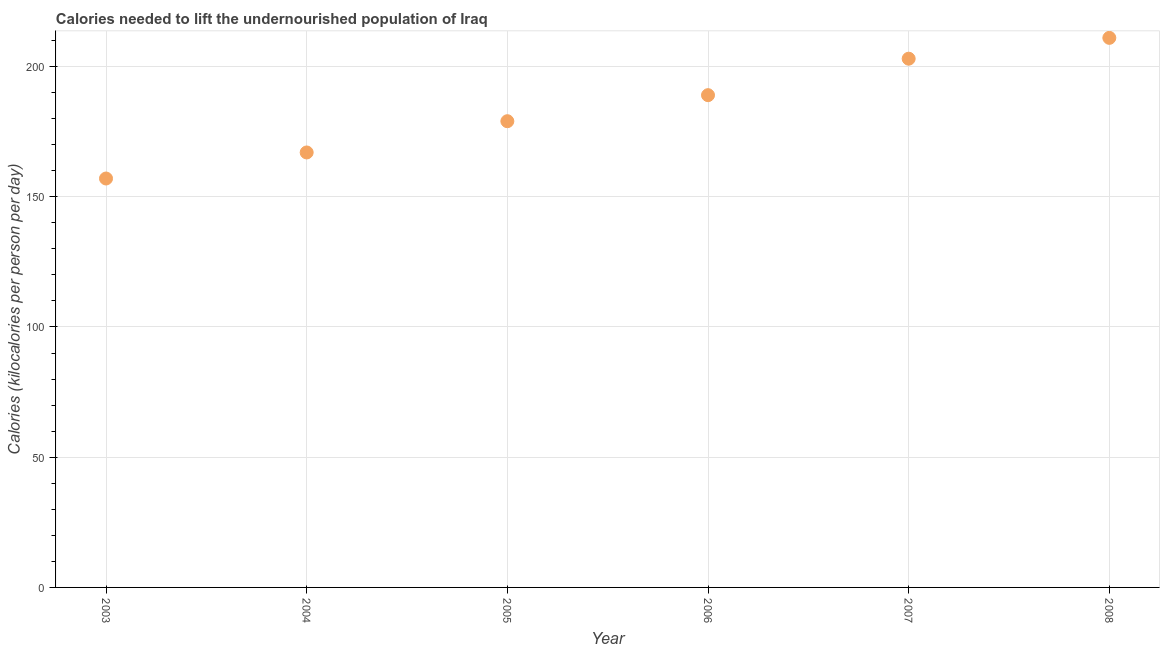What is the depth of food deficit in 2004?
Your answer should be very brief. 167. Across all years, what is the maximum depth of food deficit?
Your answer should be very brief. 211. Across all years, what is the minimum depth of food deficit?
Give a very brief answer. 157. In which year was the depth of food deficit maximum?
Your answer should be very brief. 2008. What is the sum of the depth of food deficit?
Give a very brief answer. 1106. What is the difference between the depth of food deficit in 2004 and 2005?
Your answer should be very brief. -12. What is the average depth of food deficit per year?
Make the answer very short. 184.33. What is the median depth of food deficit?
Offer a very short reply. 184. What is the ratio of the depth of food deficit in 2003 to that in 2008?
Make the answer very short. 0.74. Is the depth of food deficit in 2003 less than that in 2008?
Offer a terse response. Yes. What is the difference between the highest and the second highest depth of food deficit?
Offer a terse response. 8. What is the difference between the highest and the lowest depth of food deficit?
Keep it short and to the point. 54. In how many years, is the depth of food deficit greater than the average depth of food deficit taken over all years?
Your answer should be very brief. 3. How many years are there in the graph?
Give a very brief answer. 6. What is the difference between two consecutive major ticks on the Y-axis?
Offer a terse response. 50. Are the values on the major ticks of Y-axis written in scientific E-notation?
Your response must be concise. No. What is the title of the graph?
Your response must be concise. Calories needed to lift the undernourished population of Iraq. What is the label or title of the Y-axis?
Offer a terse response. Calories (kilocalories per person per day). What is the Calories (kilocalories per person per day) in 2003?
Your response must be concise. 157. What is the Calories (kilocalories per person per day) in 2004?
Offer a terse response. 167. What is the Calories (kilocalories per person per day) in 2005?
Ensure brevity in your answer.  179. What is the Calories (kilocalories per person per day) in 2006?
Offer a very short reply. 189. What is the Calories (kilocalories per person per day) in 2007?
Your response must be concise. 203. What is the Calories (kilocalories per person per day) in 2008?
Make the answer very short. 211. What is the difference between the Calories (kilocalories per person per day) in 2003 and 2004?
Your response must be concise. -10. What is the difference between the Calories (kilocalories per person per day) in 2003 and 2006?
Keep it short and to the point. -32. What is the difference between the Calories (kilocalories per person per day) in 2003 and 2007?
Ensure brevity in your answer.  -46. What is the difference between the Calories (kilocalories per person per day) in 2003 and 2008?
Provide a succinct answer. -54. What is the difference between the Calories (kilocalories per person per day) in 2004 and 2005?
Provide a succinct answer. -12. What is the difference between the Calories (kilocalories per person per day) in 2004 and 2006?
Your answer should be compact. -22. What is the difference between the Calories (kilocalories per person per day) in 2004 and 2007?
Make the answer very short. -36. What is the difference between the Calories (kilocalories per person per day) in 2004 and 2008?
Keep it short and to the point. -44. What is the difference between the Calories (kilocalories per person per day) in 2005 and 2007?
Give a very brief answer. -24. What is the difference between the Calories (kilocalories per person per day) in 2005 and 2008?
Offer a terse response. -32. What is the difference between the Calories (kilocalories per person per day) in 2006 and 2007?
Give a very brief answer. -14. What is the difference between the Calories (kilocalories per person per day) in 2006 and 2008?
Your response must be concise. -22. What is the difference between the Calories (kilocalories per person per day) in 2007 and 2008?
Ensure brevity in your answer.  -8. What is the ratio of the Calories (kilocalories per person per day) in 2003 to that in 2005?
Your answer should be very brief. 0.88. What is the ratio of the Calories (kilocalories per person per day) in 2003 to that in 2006?
Keep it short and to the point. 0.83. What is the ratio of the Calories (kilocalories per person per day) in 2003 to that in 2007?
Provide a short and direct response. 0.77. What is the ratio of the Calories (kilocalories per person per day) in 2003 to that in 2008?
Provide a succinct answer. 0.74. What is the ratio of the Calories (kilocalories per person per day) in 2004 to that in 2005?
Keep it short and to the point. 0.93. What is the ratio of the Calories (kilocalories per person per day) in 2004 to that in 2006?
Make the answer very short. 0.88. What is the ratio of the Calories (kilocalories per person per day) in 2004 to that in 2007?
Offer a terse response. 0.82. What is the ratio of the Calories (kilocalories per person per day) in 2004 to that in 2008?
Ensure brevity in your answer.  0.79. What is the ratio of the Calories (kilocalories per person per day) in 2005 to that in 2006?
Make the answer very short. 0.95. What is the ratio of the Calories (kilocalories per person per day) in 2005 to that in 2007?
Offer a very short reply. 0.88. What is the ratio of the Calories (kilocalories per person per day) in 2005 to that in 2008?
Ensure brevity in your answer.  0.85. What is the ratio of the Calories (kilocalories per person per day) in 2006 to that in 2007?
Provide a succinct answer. 0.93. What is the ratio of the Calories (kilocalories per person per day) in 2006 to that in 2008?
Offer a very short reply. 0.9. 